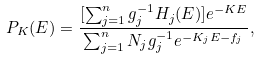<formula> <loc_0><loc_0><loc_500><loc_500>P _ { K } ( E ) = \frac { [ \sum _ { j = 1 } ^ { n } g _ { j } ^ { - 1 } H _ { j } ( E ) ] e ^ { - K E } } { \sum _ { j = 1 } ^ { n } N _ { j } g _ { j } ^ { - 1 } e ^ { - K _ { j } E - f _ { j } } } ,</formula> 